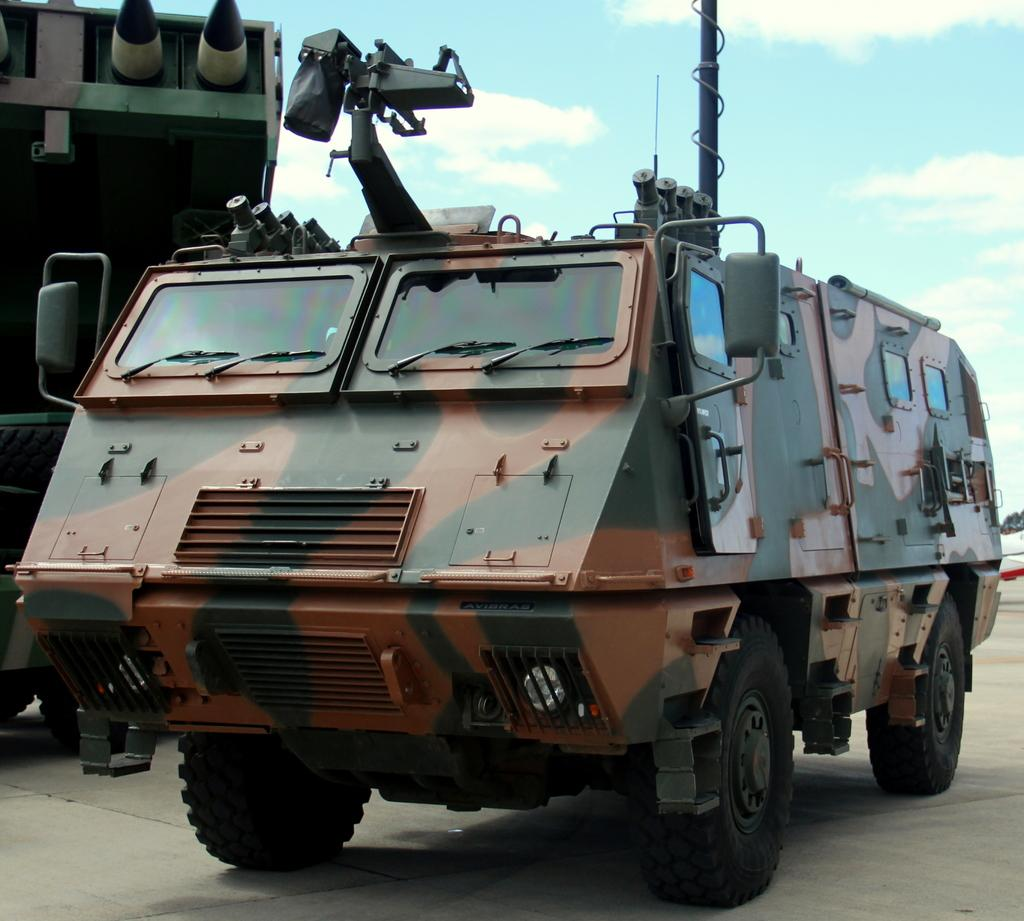What is the main subject on the ground in the image? There is a vehicle on the ground in the image. What else can be seen in the image besides the vehicle? There are objects visible in the image. What is visible in the background of the image? The sky is visible in the background of the image. What can be observed in the sky? Clouds are present in the sky. What type of nail is being used to hold the tent in the image? There is no nail or tent present in the image; it only features a vehicle and objects on the ground, with clouds visible in the sky. 